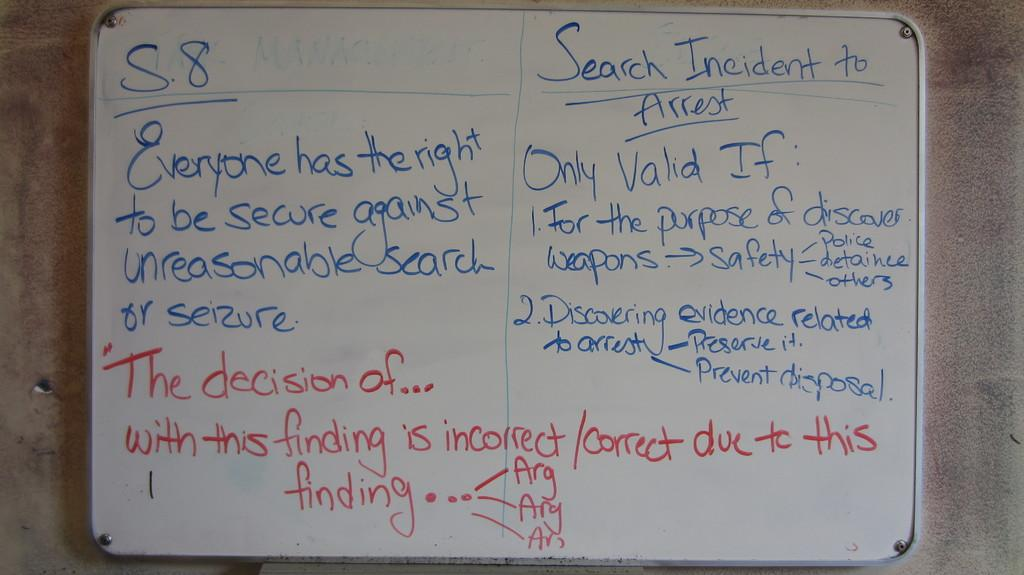<image>
Describe the image concisely. A white board has a lot of text written on it pertaining to searches. 